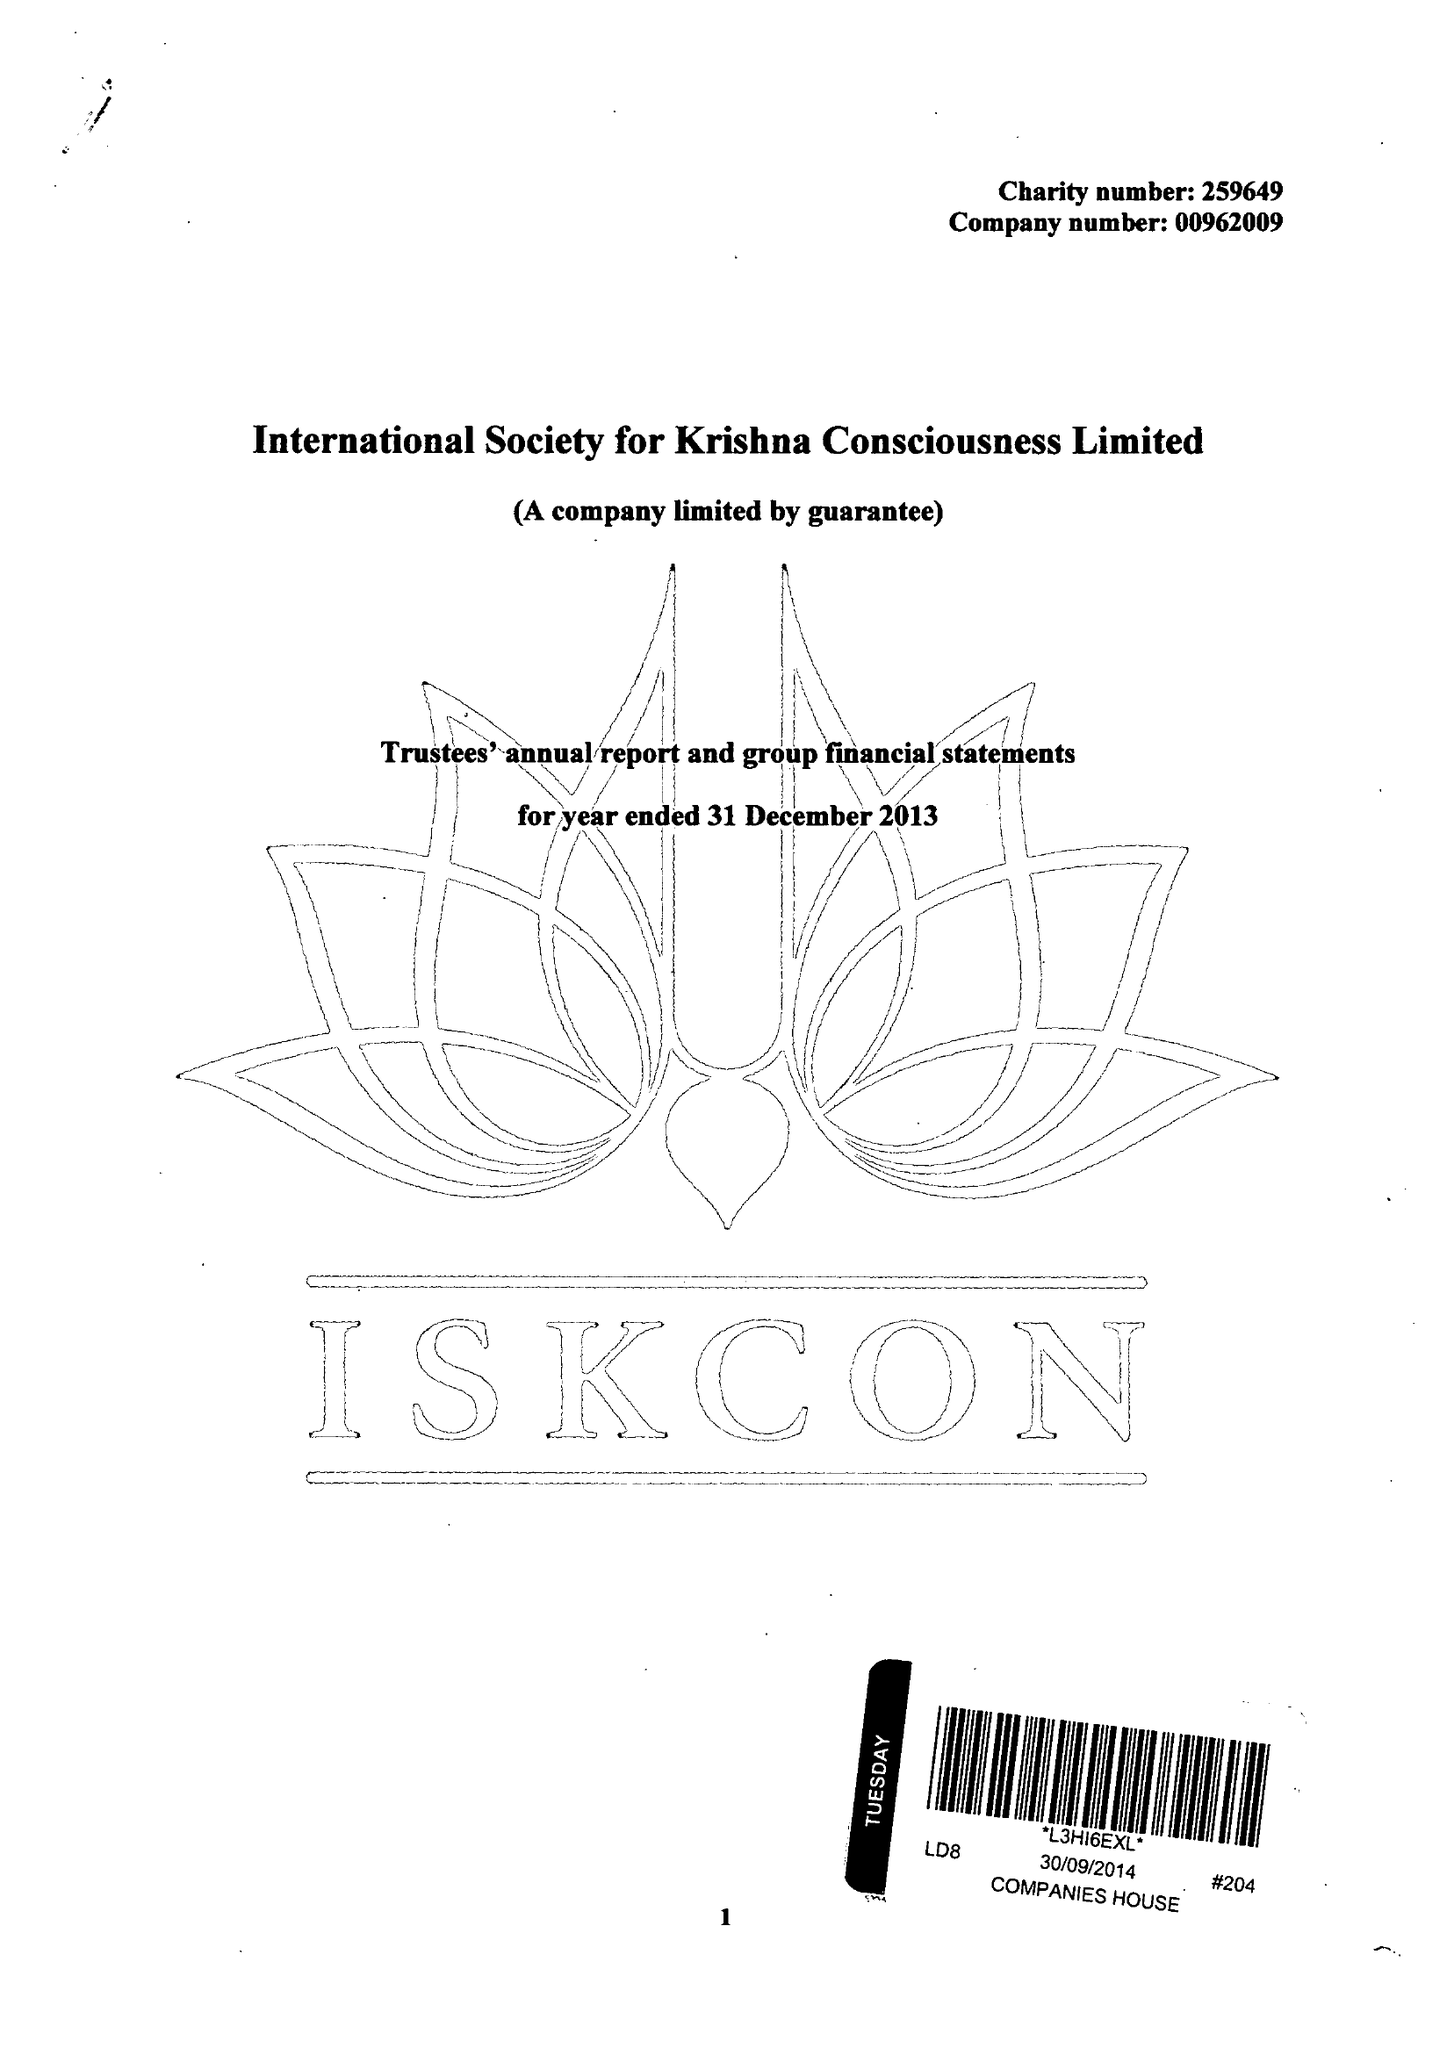What is the value for the address__post_town?
Answer the question using a single word or phrase. RADLETT 